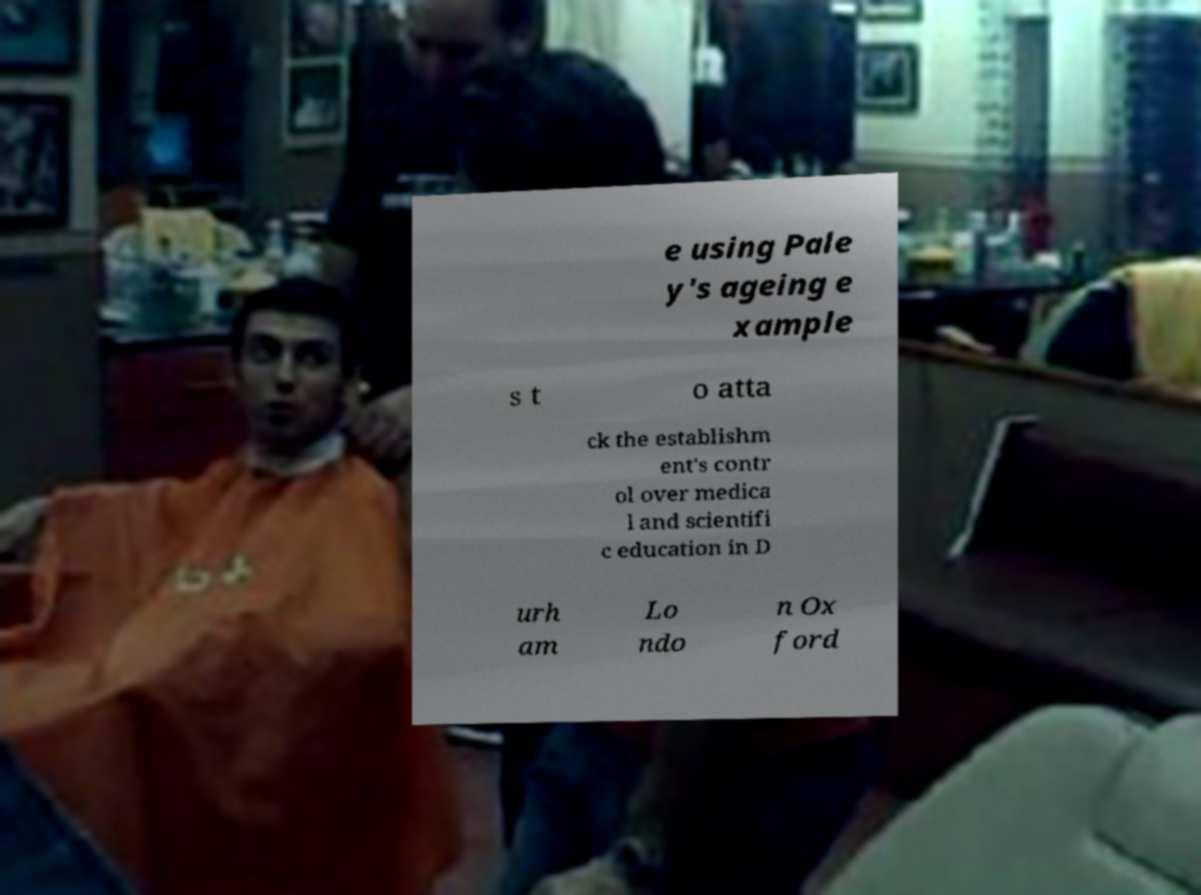Could you assist in decoding the text presented in this image and type it out clearly? e using Pale y's ageing e xample s t o atta ck the establishm ent's contr ol over medica l and scientifi c education in D urh am Lo ndo n Ox ford 